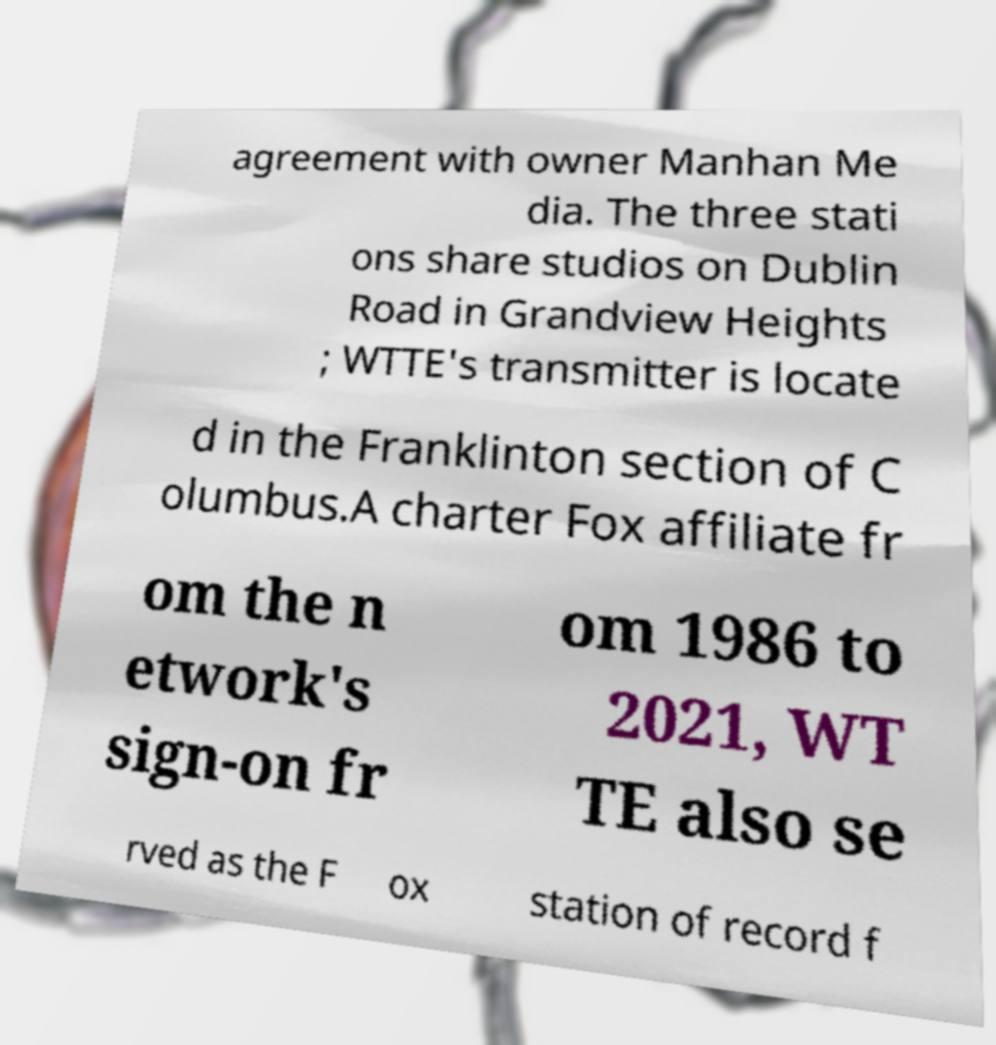Could you extract and type out the text from this image? agreement with owner Manhan Me dia. The three stati ons share studios on Dublin Road in Grandview Heights ; WTTE's transmitter is locate d in the Franklinton section of C olumbus.A charter Fox affiliate fr om the n etwork's sign-on fr om 1986 to 2021, WT TE also se rved as the F ox station of record f 